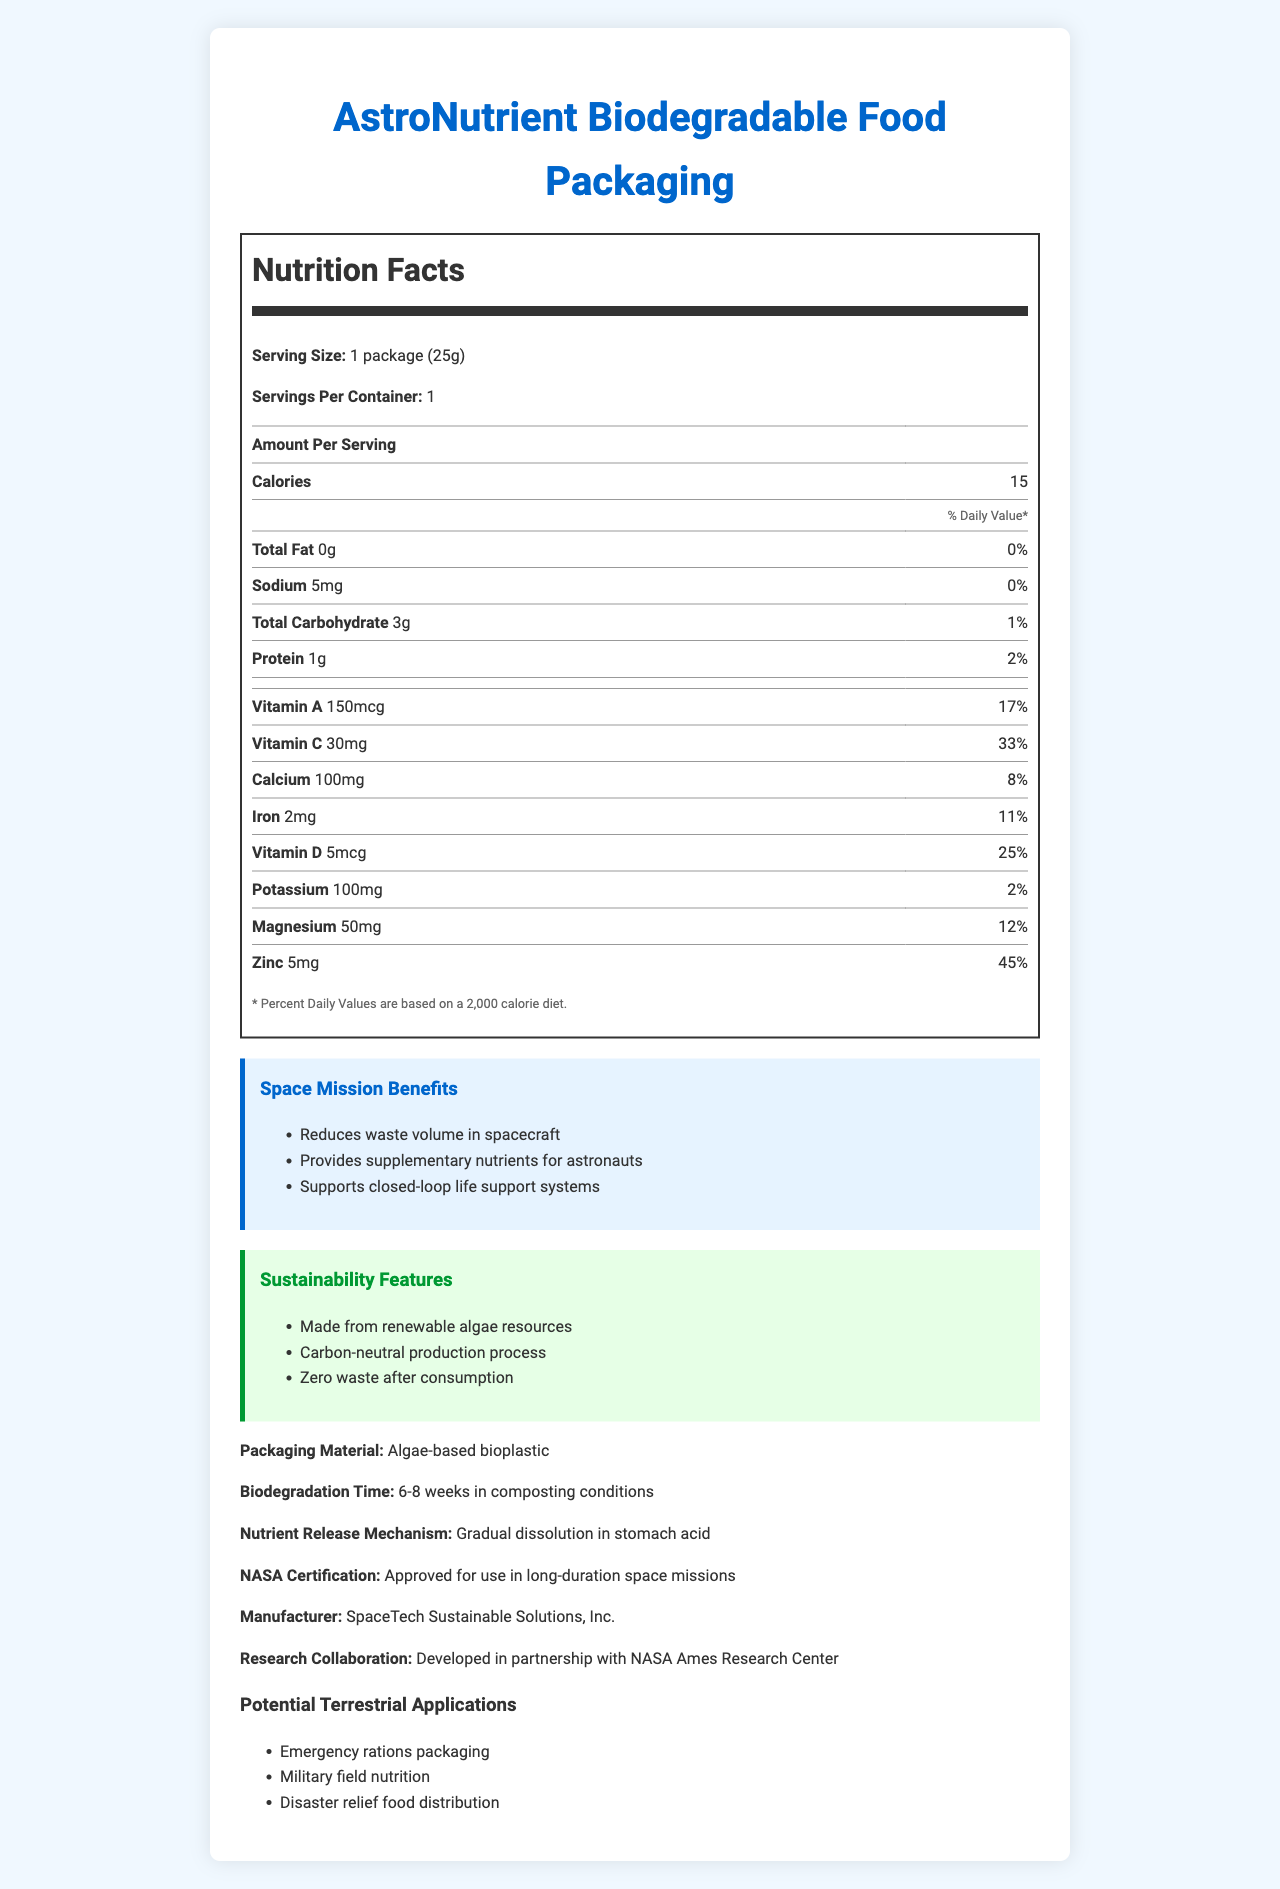what is the serving size? The serving size is explicitly stated in the nutrition facts section of the document.
Answer: 1 package (25g) how many calories are in one serving? The document clearly lists 15 calories per serving in the nutrition facts section.
Answer: 15 how many milligrams of Vitamin C does one package contain? The nutrient details section lists the amount of Vitamin C as 30mg.
Answer: 30mg what is the biodegradation time of the packaging material? The biodegradation time is listed near the bottom of the document.
Answer: 6-8 weeks in composting conditions what type of packaging material is used? The packaging material is specified in the document as "Algae-based bioplastic".
Answer: Algae-based bioplastic how much protein does one serving provide in terms of % daily value? The % daily value for protein is listed as 2% in the nutrition facts section.
Answer: 2% what are some of the space mission benefits mentioned? The document has a specific section listing the space mission benefits.
Answer: Reduces waste volume in spacecraft, Provides supplementary nutrients for astronauts, Supports closed-loop life support systems where was this product developed in partnership with? The research collaboration section mentions the partnership with NASA Ames Research Center.
Answer: NASA Ames Research Center can this document provide the exact cost of the product? The document does not mention any details regarding the cost of the product.
Answer: Not enough information which manufacturer produced this biodegradable food packaging? A. SpaceCorp B. SpaceTech Sustainable Solutions, Inc. C. Galactic Goods The manufacturer mentioned in the document is SpaceTech Sustainable Solutions, Inc.
Answer: B what is the nutrient release mechanism? A. Osmosis B. Gradual dissolution in stomach acid C. Immediate dissolution The nutrient release mechanism is stated as "Gradual dissolution in stomach acid".
Answer: B is this packaging approved for use in long-duration space missions? The document states that the product is NASA certified for use in long-duration space missions.
Answer: Yes given the nutrition facts, is this packaging a significant source of fat? The total fat content is 0g, which indicates it is not a significant source of fat.
Answer: No summarize the main features of the AstroNutrient Biodegradable Food Packaging. This summary describes the main aspects of the biodegradable food packaging, such as its nutrient content, biodegradation time, benefits for space missions, certification, and potential terrestrial applications.
Answer: The AstroNutrient Biodegradable Food Packaging contains embedded nutrient supplements and is made from algae-based bioplastic. It has a serving size of 25g and provides various nutrients such as Vitamin A, Vitamin C, Calcium, Iron, Vitamin D, Potassium, Magnesium, and Zinc. It is designed to biodegrade in 6-8 weeks under composting conditions and offers several benefits for space missions, including waste reduction and supplementary nutrition for astronauts. This product is NASA certified and developed in partnership with the NASA Ames Research Center, with terrestrial applications like emergency rations, military nutrition, and disaster relief. 